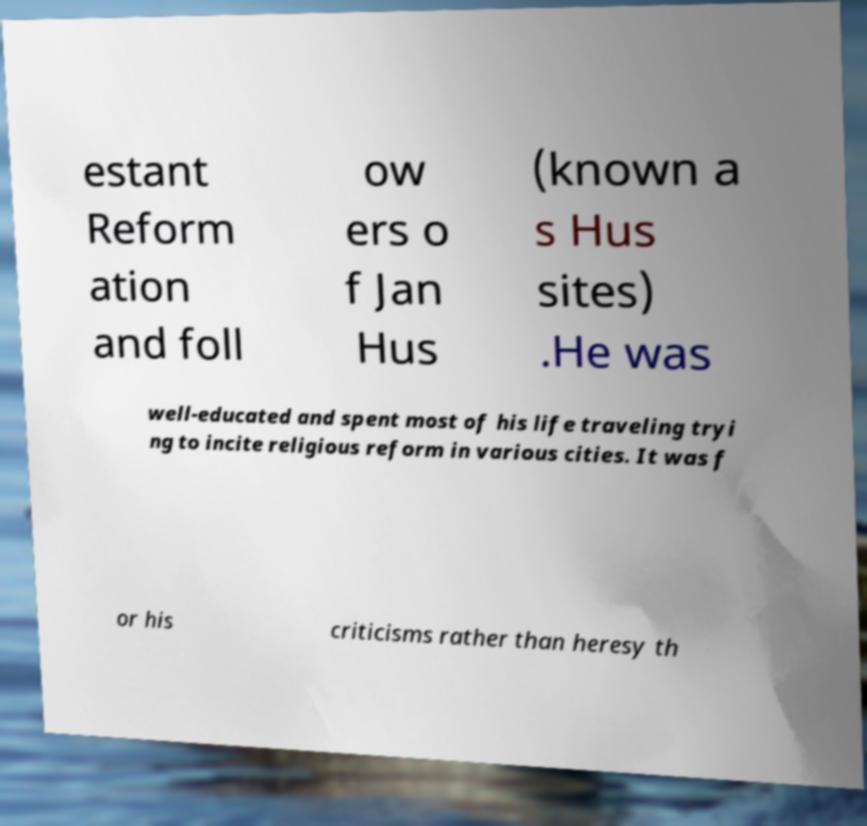Please read and relay the text visible in this image. What does it say? estant Reform ation and foll ow ers o f Jan Hus (known a s Hus sites) .He was well-educated and spent most of his life traveling tryi ng to incite religious reform in various cities. It was f or his criticisms rather than heresy th 